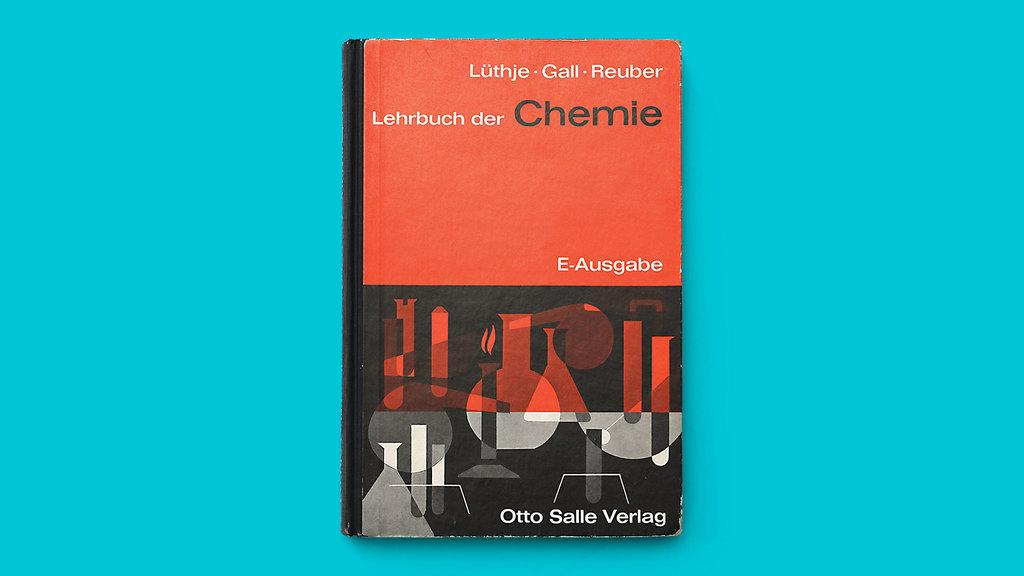<image>
Summarize the visual content of the image. A book with the title Lehrbuch der Chemie by Otto Salle Verlag. 